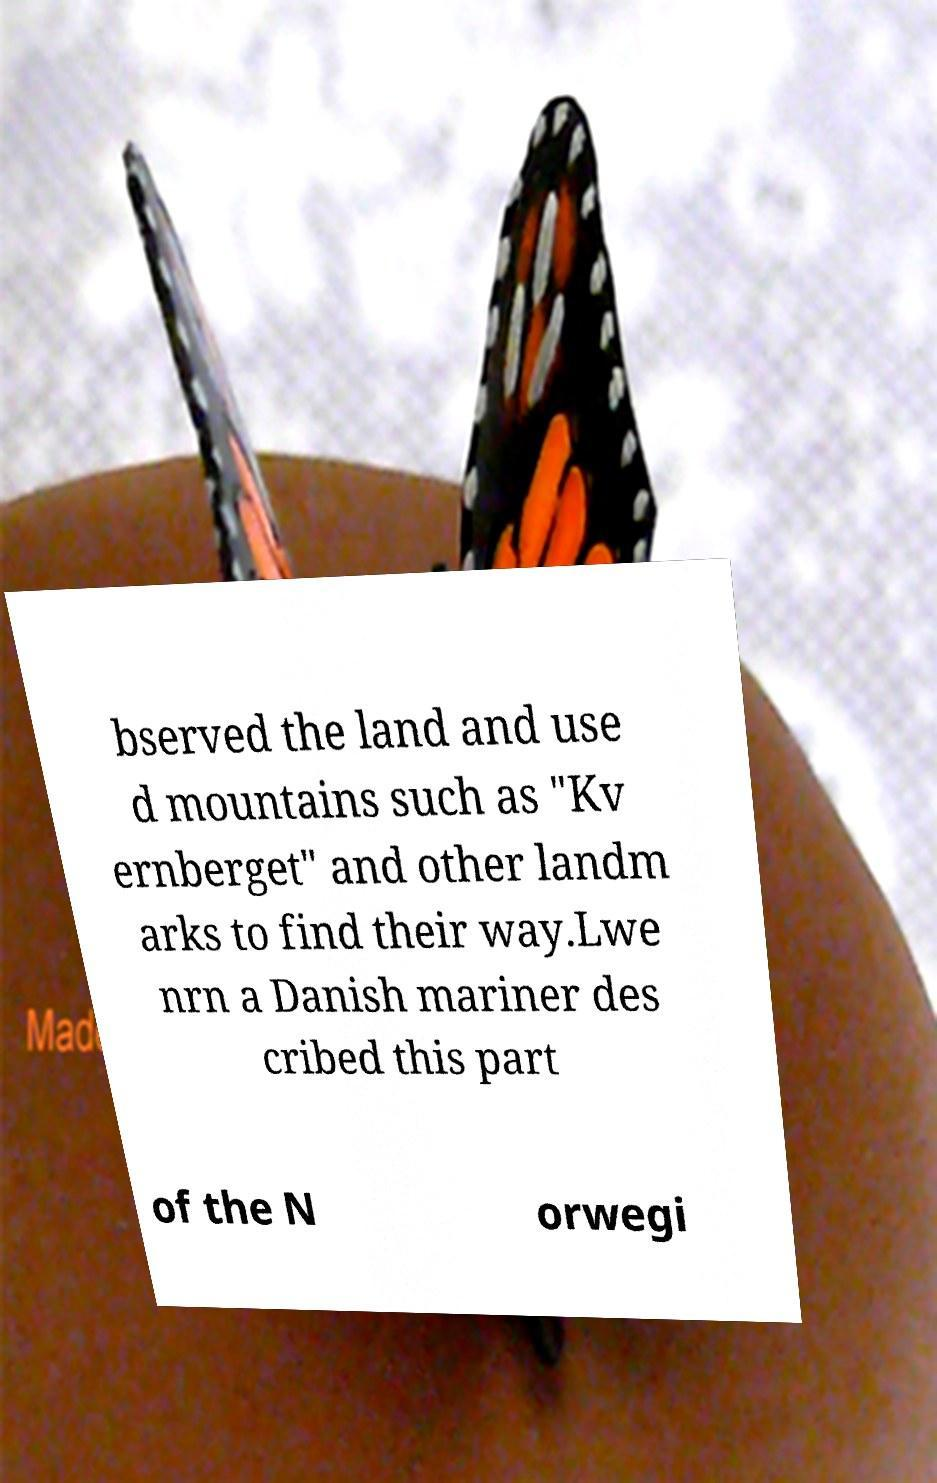I need the written content from this picture converted into text. Can you do that? bserved the land and use d mountains such as "Kv ernberget" and other landm arks to find their way.Lwe nrn a Danish mariner des cribed this part of the N orwegi 